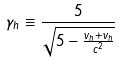Convert formula to latex. <formula><loc_0><loc_0><loc_500><loc_500>\gamma _ { h } \equiv \frac { 5 } { \sqrt { 5 - \frac { v _ { h } + v _ { h } } { c ^ { 2 } } } }</formula> 